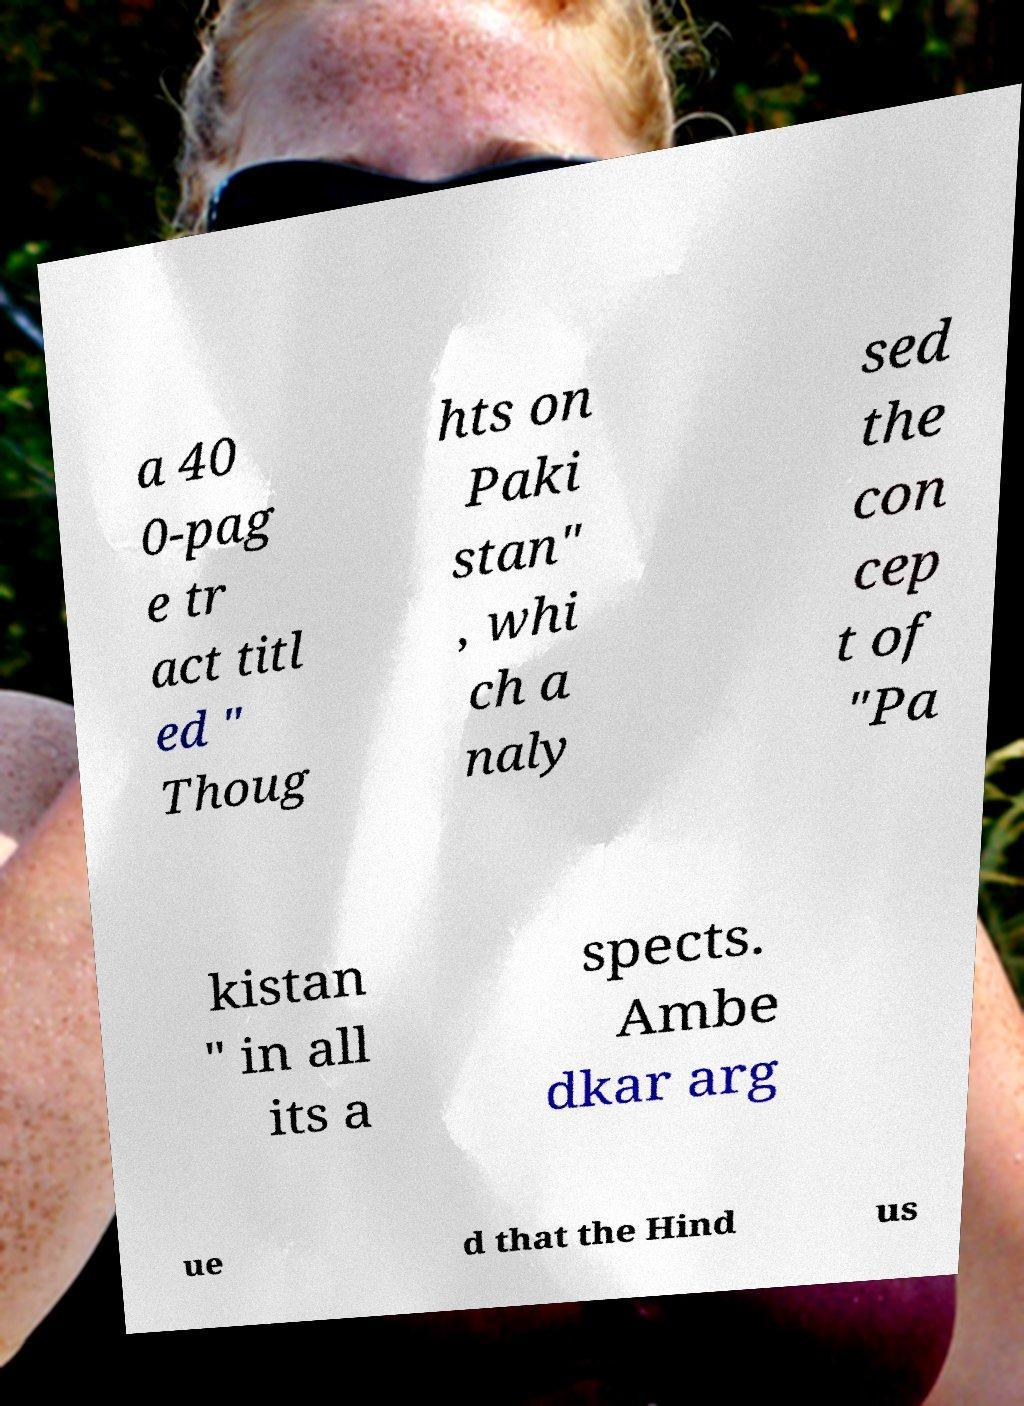What messages or text are displayed in this image? I need them in a readable, typed format. a 40 0-pag e tr act titl ed " Thoug hts on Paki stan" , whi ch a naly sed the con cep t of "Pa kistan " in all its a spects. Ambe dkar arg ue d that the Hind us 